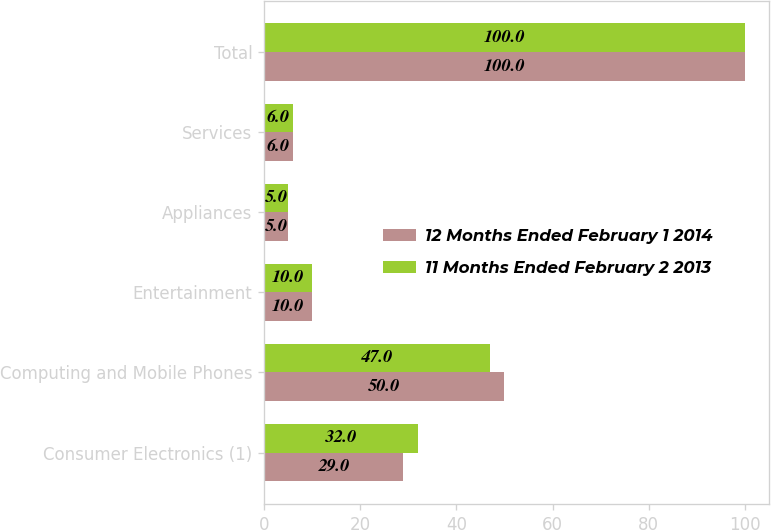<chart> <loc_0><loc_0><loc_500><loc_500><stacked_bar_chart><ecel><fcel>Consumer Electronics (1)<fcel>Computing and Mobile Phones<fcel>Entertainment<fcel>Appliances<fcel>Services<fcel>Total<nl><fcel>12 Months Ended February 1 2014<fcel>29<fcel>50<fcel>10<fcel>5<fcel>6<fcel>100<nl><fcel>11 Months Ended February 2 2013<fcel>32<fcel>47<fcel>10<fcel>5<fcel>6<fcel>100<nl></chart> 